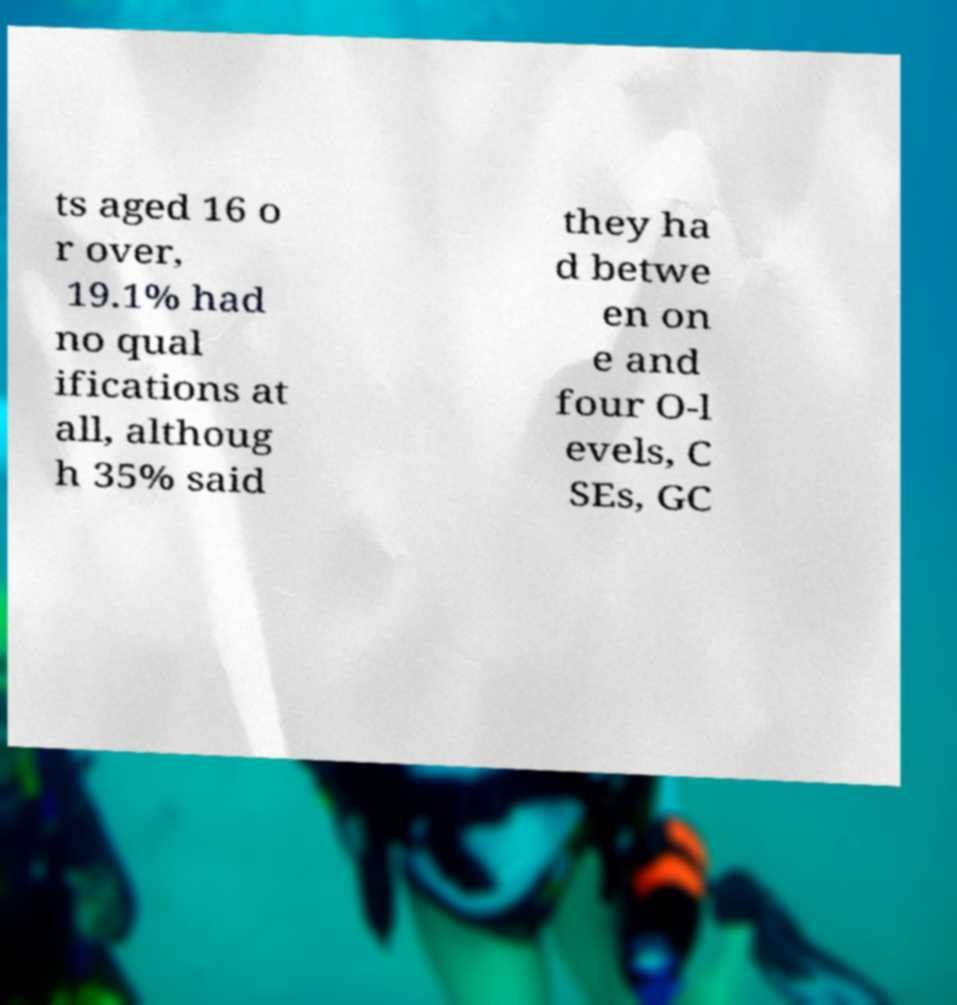Can you accurately transcribe the text from the provided image for me? ts aged 16 o r over, 19.1% had no qual ifications at all, althoug h 35% said they ha d betwe en on e and four O-l evels, C SEs, GC 